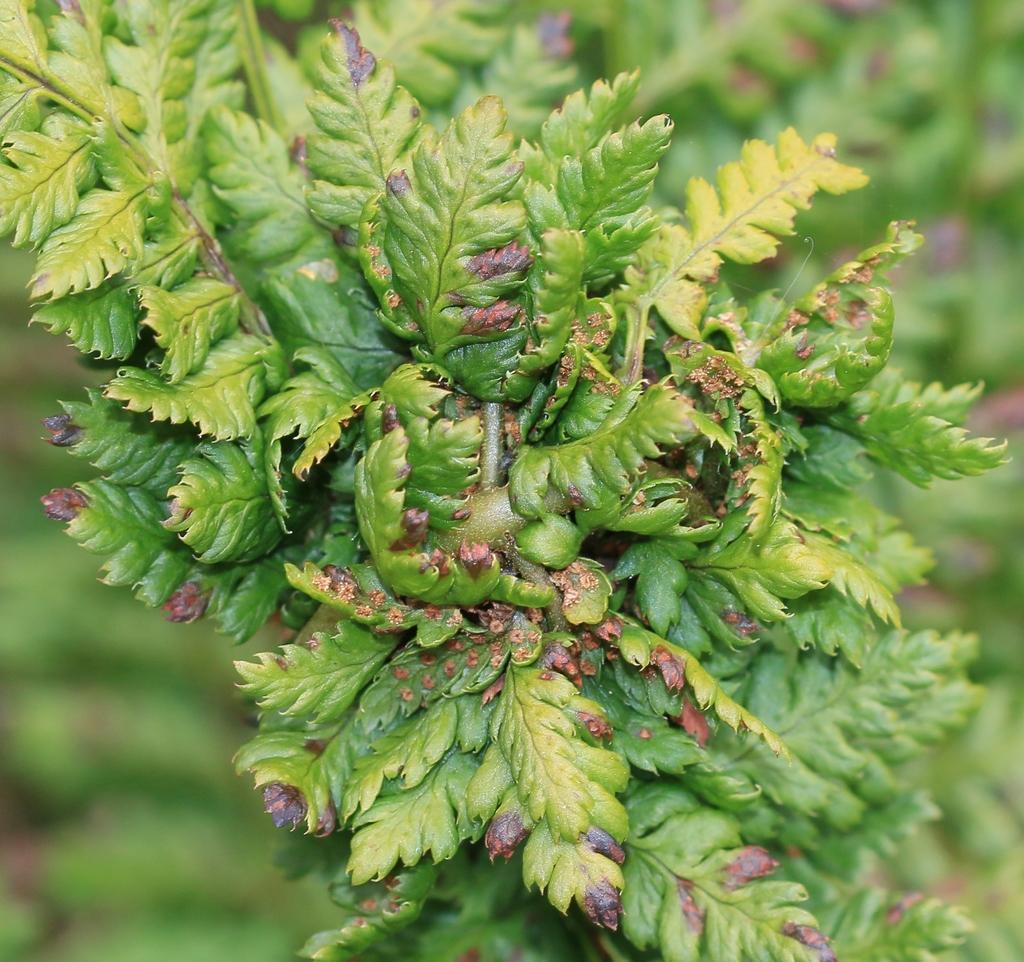Could you give a brief overview of what you see in this image? In this picture I can see number of leaves in front and I see that it is green color in the background and I see that it is blurry. 